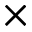Convert formula to latex. <formula><loc_0><loc_0><loc_500><loc_500>\times</formula> 